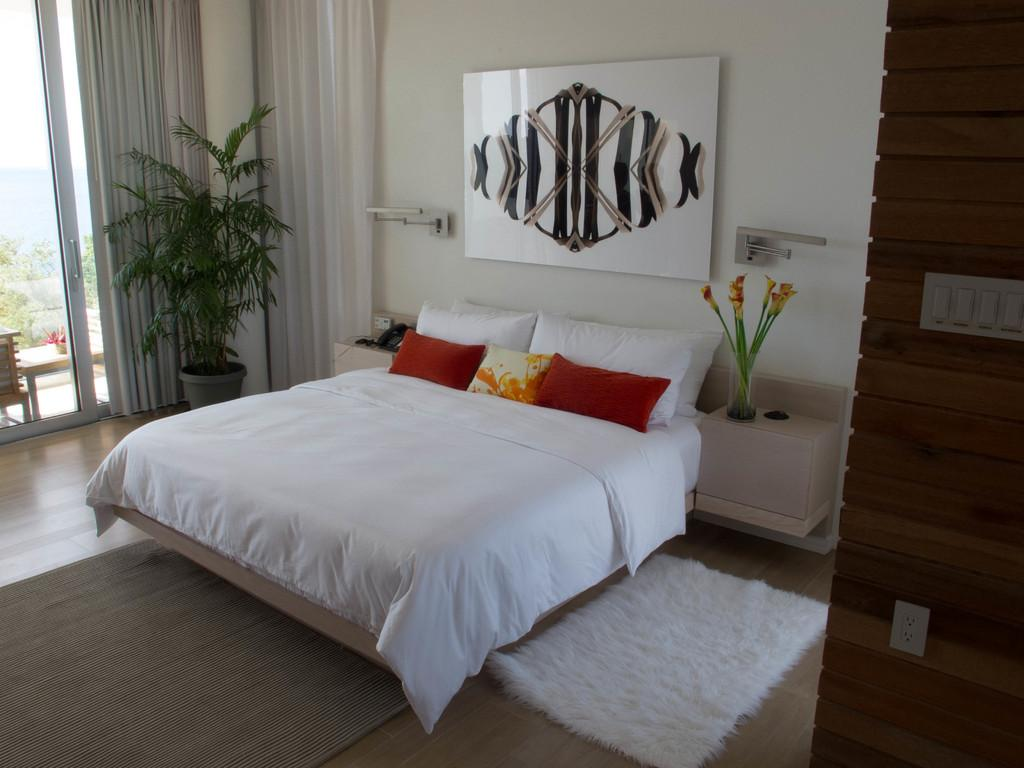What type of furniture is in the image? There is a bed in the image. What color is the bed? The bed is white. What can be found on the bed? There are pillows on the bed. What type of vegetation is in the image? There is a plant in the image. Where is the plant located in relation to the glass wall? The plant is near a glass wall. What type of spade is being used to dig near the plant in the image? There is no spade present in the image; it only features a bed, pillows, a plant, and a glass wall. 